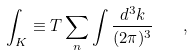Convert formula to latex. <formula><loc_0><loc_0><loc_500><loc_500>\int _ { K } \equiv T \sum _ { n } \int \frac { d ^ { 3 } k } { ( 2 \pi ) ^ { 3 } } \quad ,</formula> 